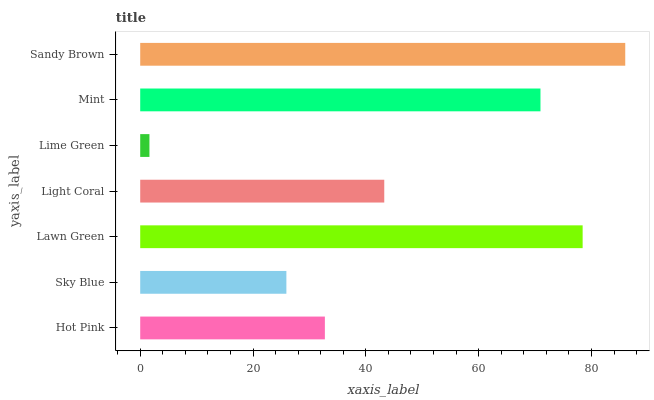Is Lime Green the minimum?
Answer yes or no. Yes. Is Sandy Brown the maximum?
Answer yes or no. Yes. Is Sky Blue the minimum?
Answer yes or no. No. Is Sky Blue the maximum?
Answer yes or no. No. Is Hot Pink greater than Sky Blue?
Answer yes or no. Yes. Is Sky Blue less than Hot Pink?
Answer yes or no. Yes. Is Sky Blue greater than Hot Pink?
Answer yes or no. No. Is Hot Pink less than Sky Blue?
Answer yes or no. No. Is Light Coral the high median?
Answer yes or no. Yes. Is Light Coral the low median?
Answer yes or no. Yes. Is Lime Green the high median?
Answer yes or no. No. Is Sandy Brown the low median?
Answer yes or no. No. 